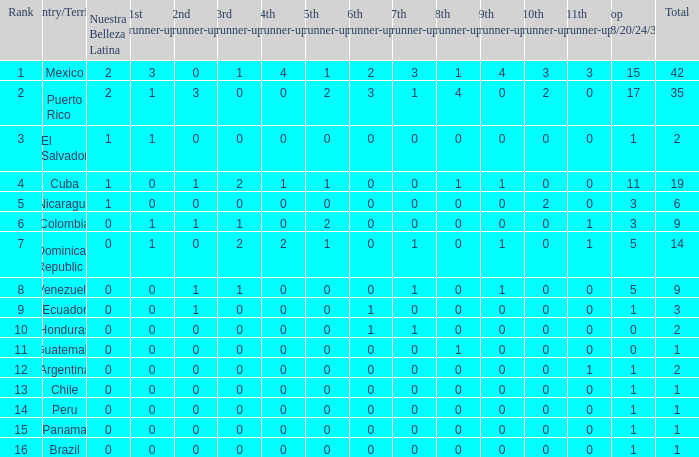In a country with more than zero ninth runner-ups, no eleventh runner-ups, and at least one first runner-up, who is the third runner-up? None. 